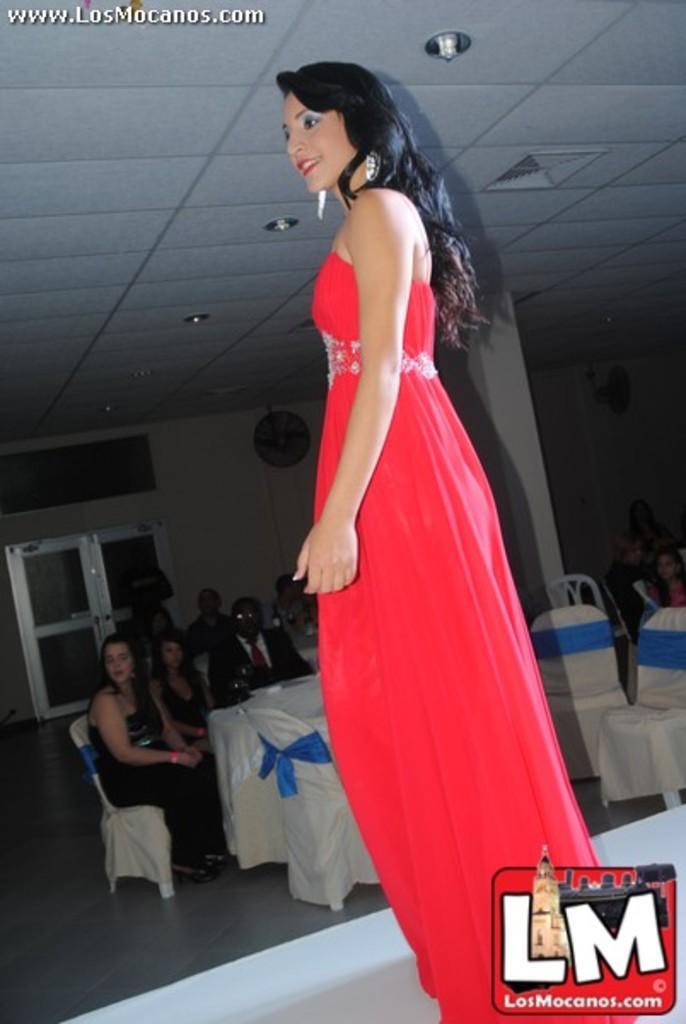Describe this image in one or two sentences. This image consists of a woman. She is wearing a red dress. She is standing. There are chairs in the middle and some persons are sitting on chairs. There are lights at the top. 